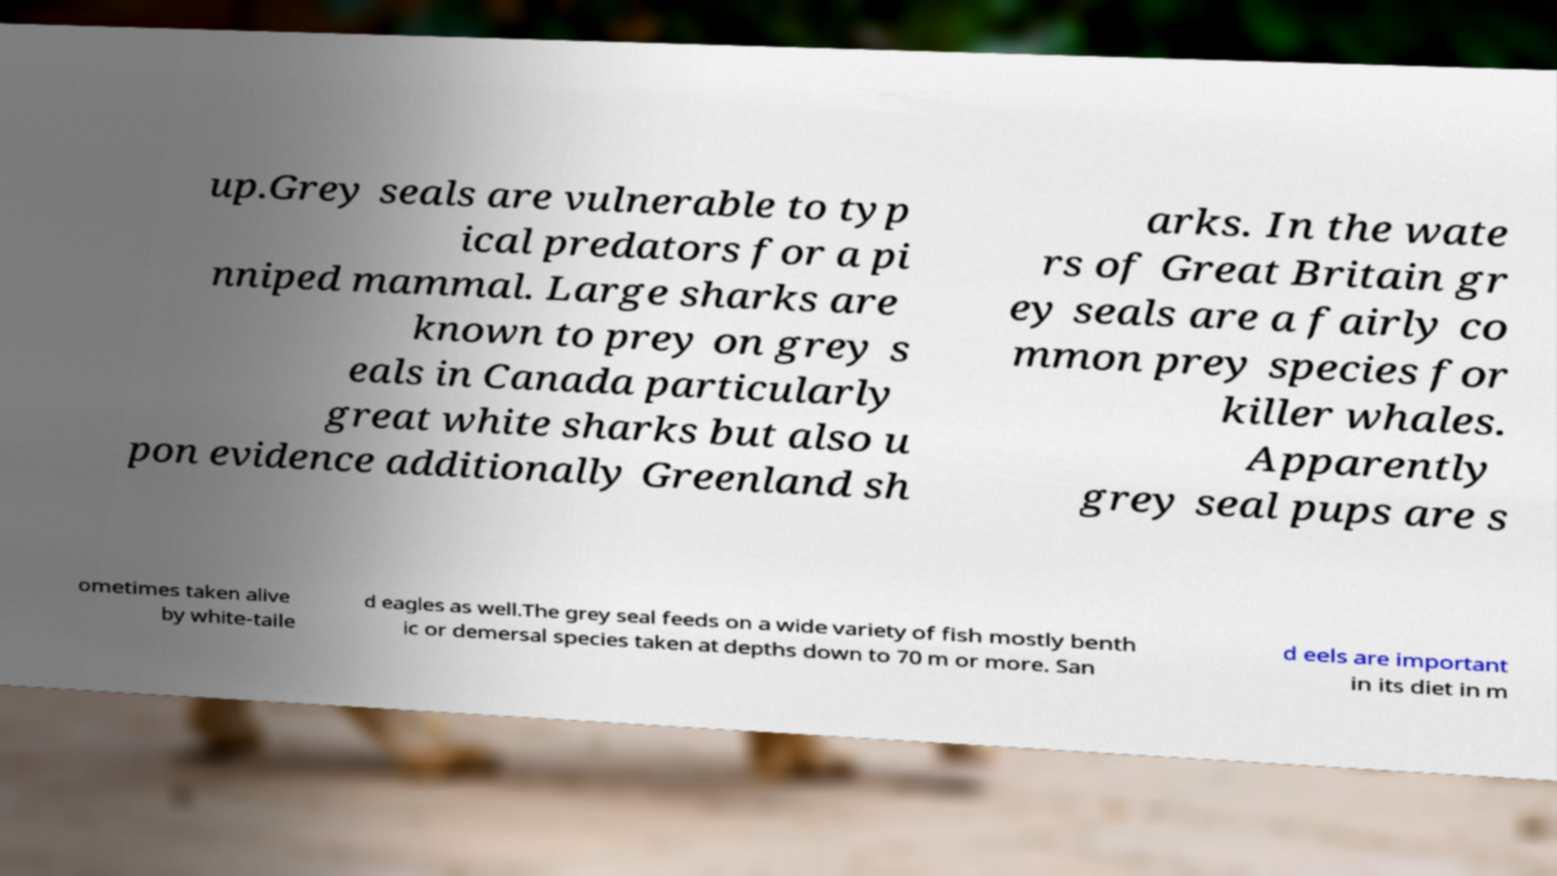Could you extract and type out the text from this image? up.Grey seals are vulnerable to typ ical predators for a pi nniped mammal. Large sharks are known to prey on grey s eals in Canada particularly great white sharks but also u pon evidence additionally Greenland sh arks. In the wate rs of Great Britain gr ey seals are a fairly co mmon prey species for killer whales. Apparently grey seal pups are s ometimes taken alive by white-taile d eagles as well.The grey seal feeds on a wide variety of fish mostly benth ic or demersal species taken at depths down to 70 m or more. San d eels are important in its diet in m 